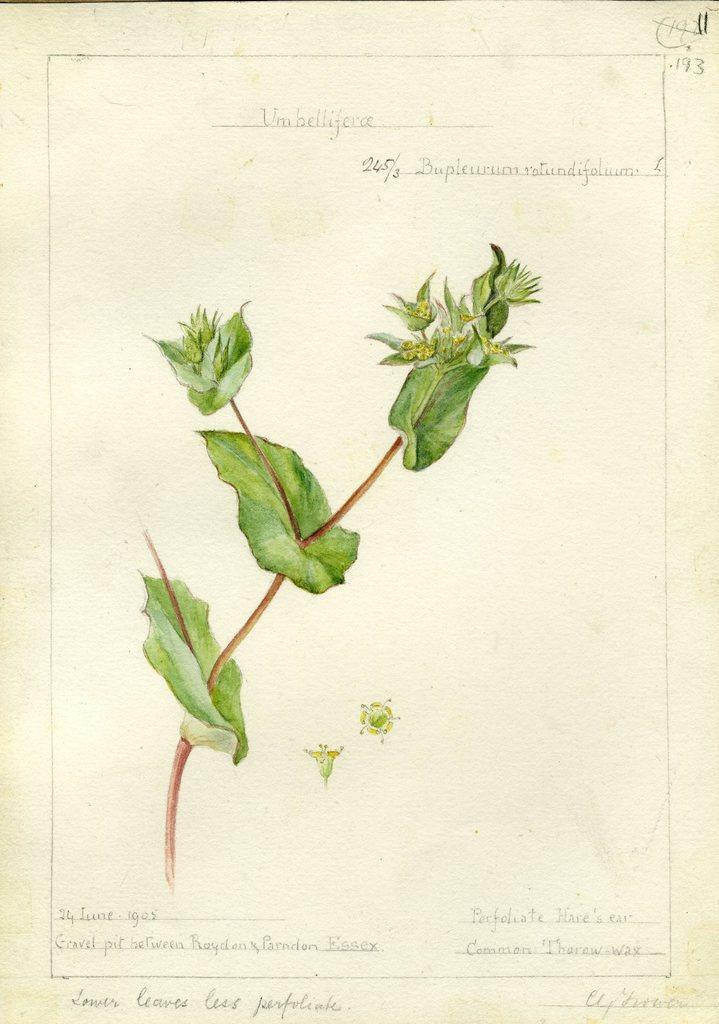Could you give a brief overview of what you see in this image? In this image we can see a poster with text and an image of a plant. 